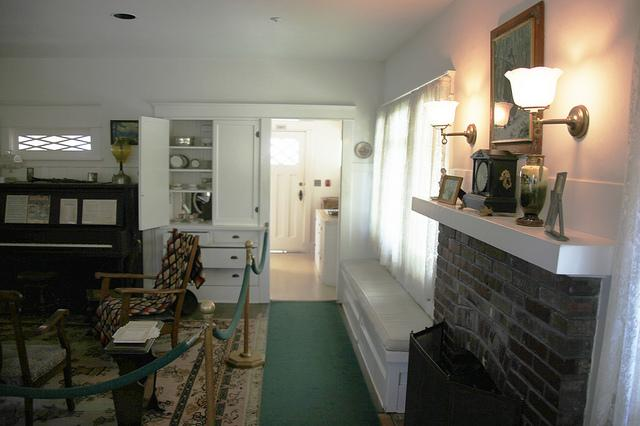What item is under the bright lights attached to the wall? mantle 